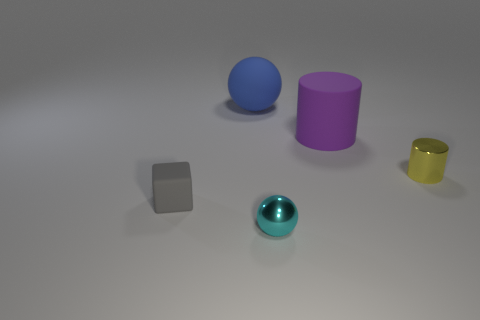How many other things are there of the same color as the matte cylinder?
Give a very brief answer. 0. Is the size of the metallic ball the same as the gray thing?
Give a very brief answer. Yes. How many objects are either metal balls or things that are behind the small ball?
Provide a succinct answer. 5. Are there fewer blue balls behind the blue matte thing than small rubber objects in front of the cube?
Ensure brevity in your answer.  No. How many other objects are there of the same material as the large cylinder?
Make the answer very short. 2. Do the sphere that is to the left of the tiny sphere and the tiny cylinder have the same color?
Offer a terse response. No. There is a ball behind the matte cylinder; are there any matte things that are in front of it?
Make the answer very short. Yes. There is a small object that is both to the right of the big blue object and behind the metallic ball; what is its material?
Your answer should be compact. Metal. There is a tiny cyan thing that is the same material as the tiny yellow thing; what is its shape?
Give a very brief answer. Sphere. Is there anything else that has the same shape as the cyan shiny thing?
Provide a short and direct response. Yes. 